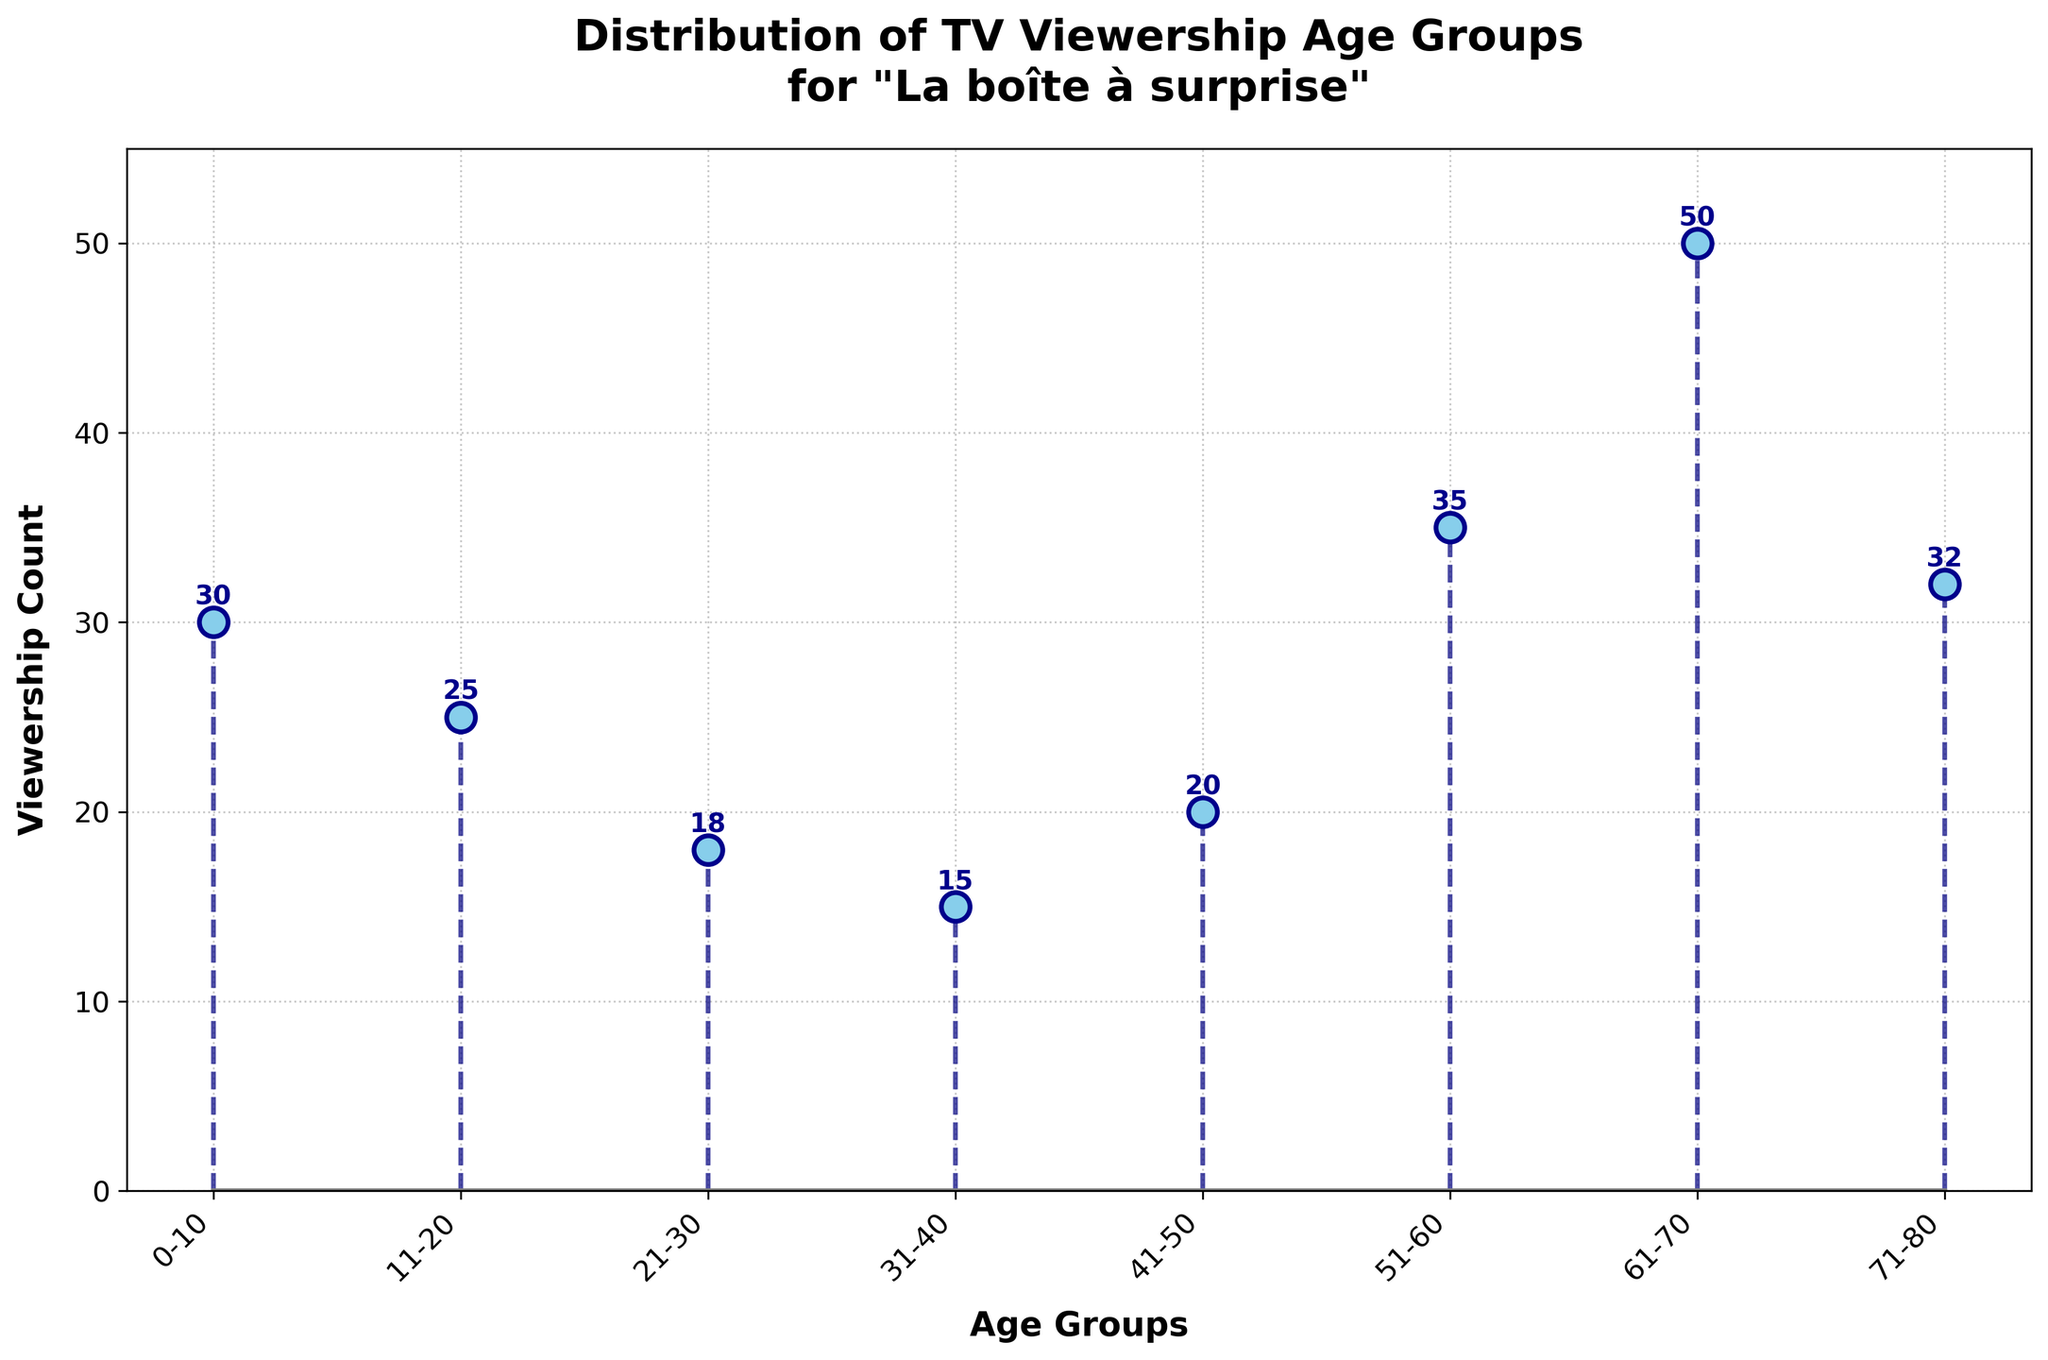How many age groups are represented in the figure? The x-axis labels each age group. By counting the labels, we see there are eight distinct age groups represented.
Answer: Eight Which age group has the highest viewership count? From the plot, the age group with the highest stem line and the number 50 annotated next to it is "61-70", indicating the highest viewership count.
Answer: 61-70 What is the total viewership count for age groups 0-10 and 71-80 combined? The viewership count for 0-10 is 30, and for 71-80 is 32. Adding these together gives 30 + 32.
Answer: 62 Are there more viewers in the age group 51-60 or in the age group 21-30? The figure shows that the 51-60 age group has a count of 35, while the 21-30 age group has a count of 18. 35 is greater than 18.
Answer: 51-60 Which age groups have viewership counts greater than 30? From the figure, the age groups 0-10, 51-60, 61-70, and 71-80 have stem lines annotated with counts greater than 30.
Answer: 0-10, 51-60, 61-70, 71-80 What is the difference in viewership counts between the 41-50 and 61-70 age groups? The figure shows the count for 41-50 is 20, and the count for 61-70 is 50. Subtracting these gives 50 - 20.
Answer: 30 What is the average viewership count for all age groups? Adding all the counts (30 + 25 + 18 + 15 + 20 + 35 + 50 + 32) gives 225. There are 8 age groups, so dividing 225 by 8 gives the average.
Answer: 28.125 Which age group is closest in viewership count to the 11-20 age group's count? The viewership count for the 11-20 age group is 25. The counts for other age groups are 30, 18, 15, 20, 35, 50, 32. The count closest to 25 is 20, corresponding to age group 41-50.
Answer: 41-50 